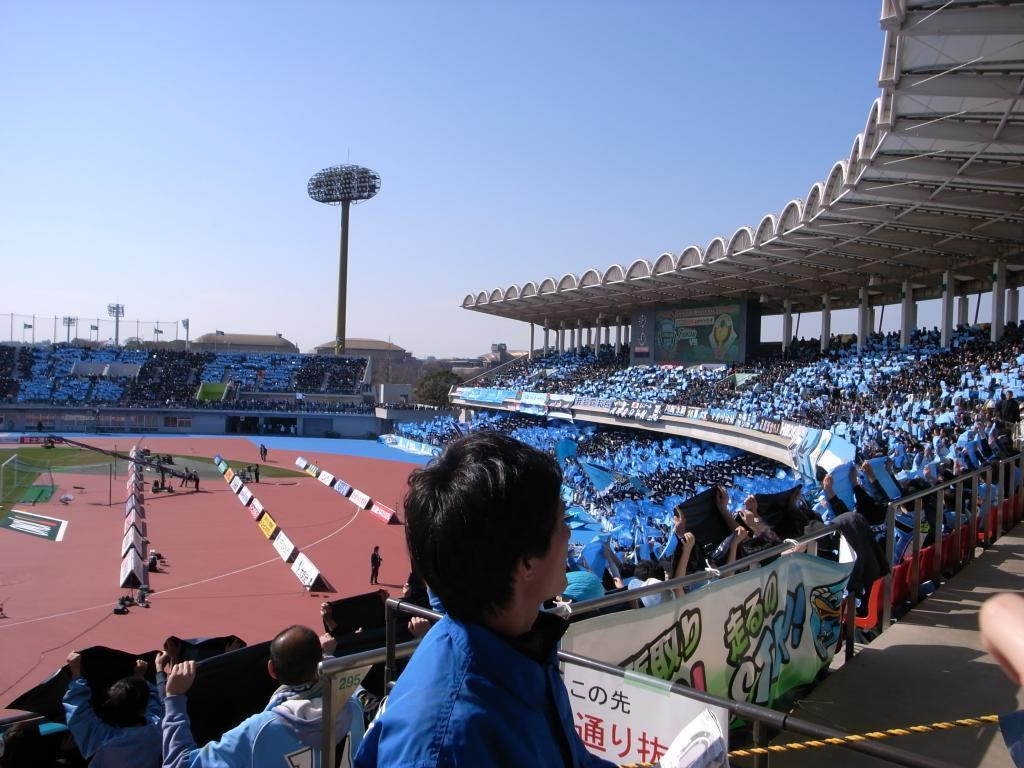How many people are in the image? There is a group of people in the image, but the exact number is not specified. What are some of the people in the image doing? Some people are sitting on chairs, while others are standing. What structures can be seen in the image? There are poles, a fence, and a net in the image. What can be seen in the background of the image? The sky is visible in the background of the image. What type of attention is the person in the image giving to the hammer? There is no hammer present in the image, so it is not possible to determine the type of attention being given to it. 